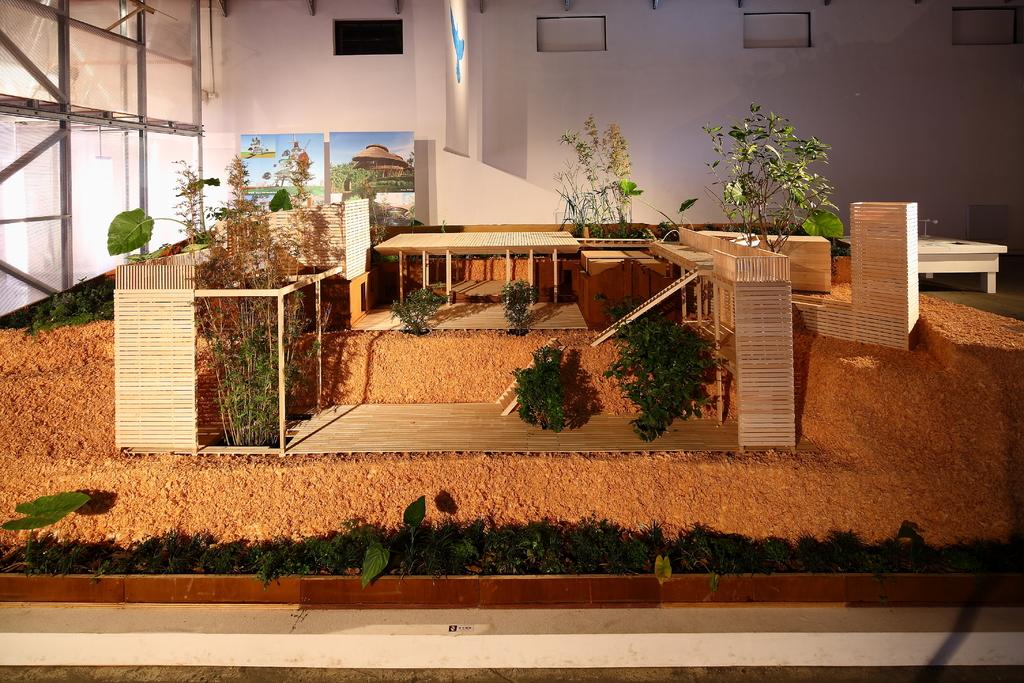What type of furniture is visible in the image? There are tables and chairs in the image. What else can be seen in the image besides furniture? Plants are present in the image. Is there any artwork visible in the image? Yes, there is a painting is on a wall in the image. Can you see a trail of bananas leading to the lake in the image? There is no trail of bananas or lake present in the image. 